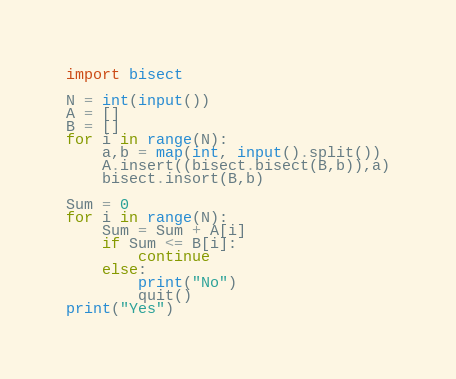<code> <loc_0><loc_0><loc_500><loc_500><_Python_>import bisect

N = int(input())
A = []
B = []
for i in range(N):
    a,b = map(int, input().split())
    A.insert((bisect.bisect(B,b)),a)
    bisect.insort(B,b)

Sum = 0
for i in range(N):
    Sum = Sum + A[i]
    if Sum <= B[i]:
        continue
    else:
        print("No")
        quit()
print("Yes")</code> 